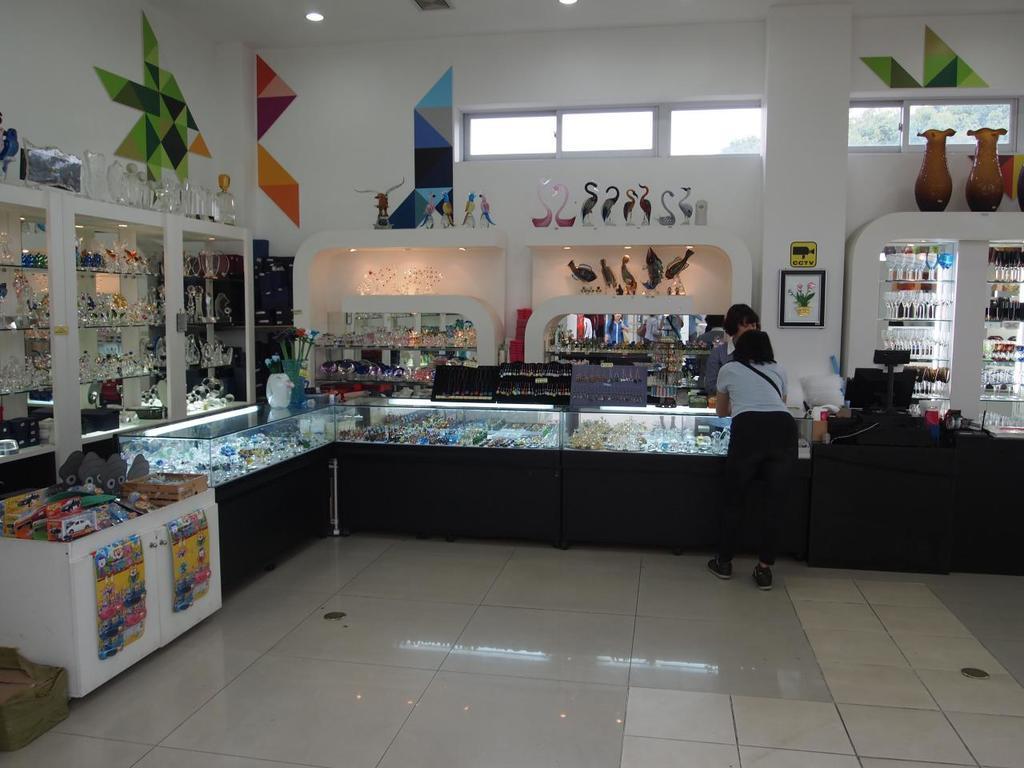Describe this image in one or two sentences. There is a monitor on a desk on the right side of the image, there are people on the right side. There are cracks on both the sides of the image and there are toys on the left side, there are flower vases on the right side, there are paintings on the wall and there are lamps on the roof at the top side. There are windows at the top side, it seems like a gallery store. 